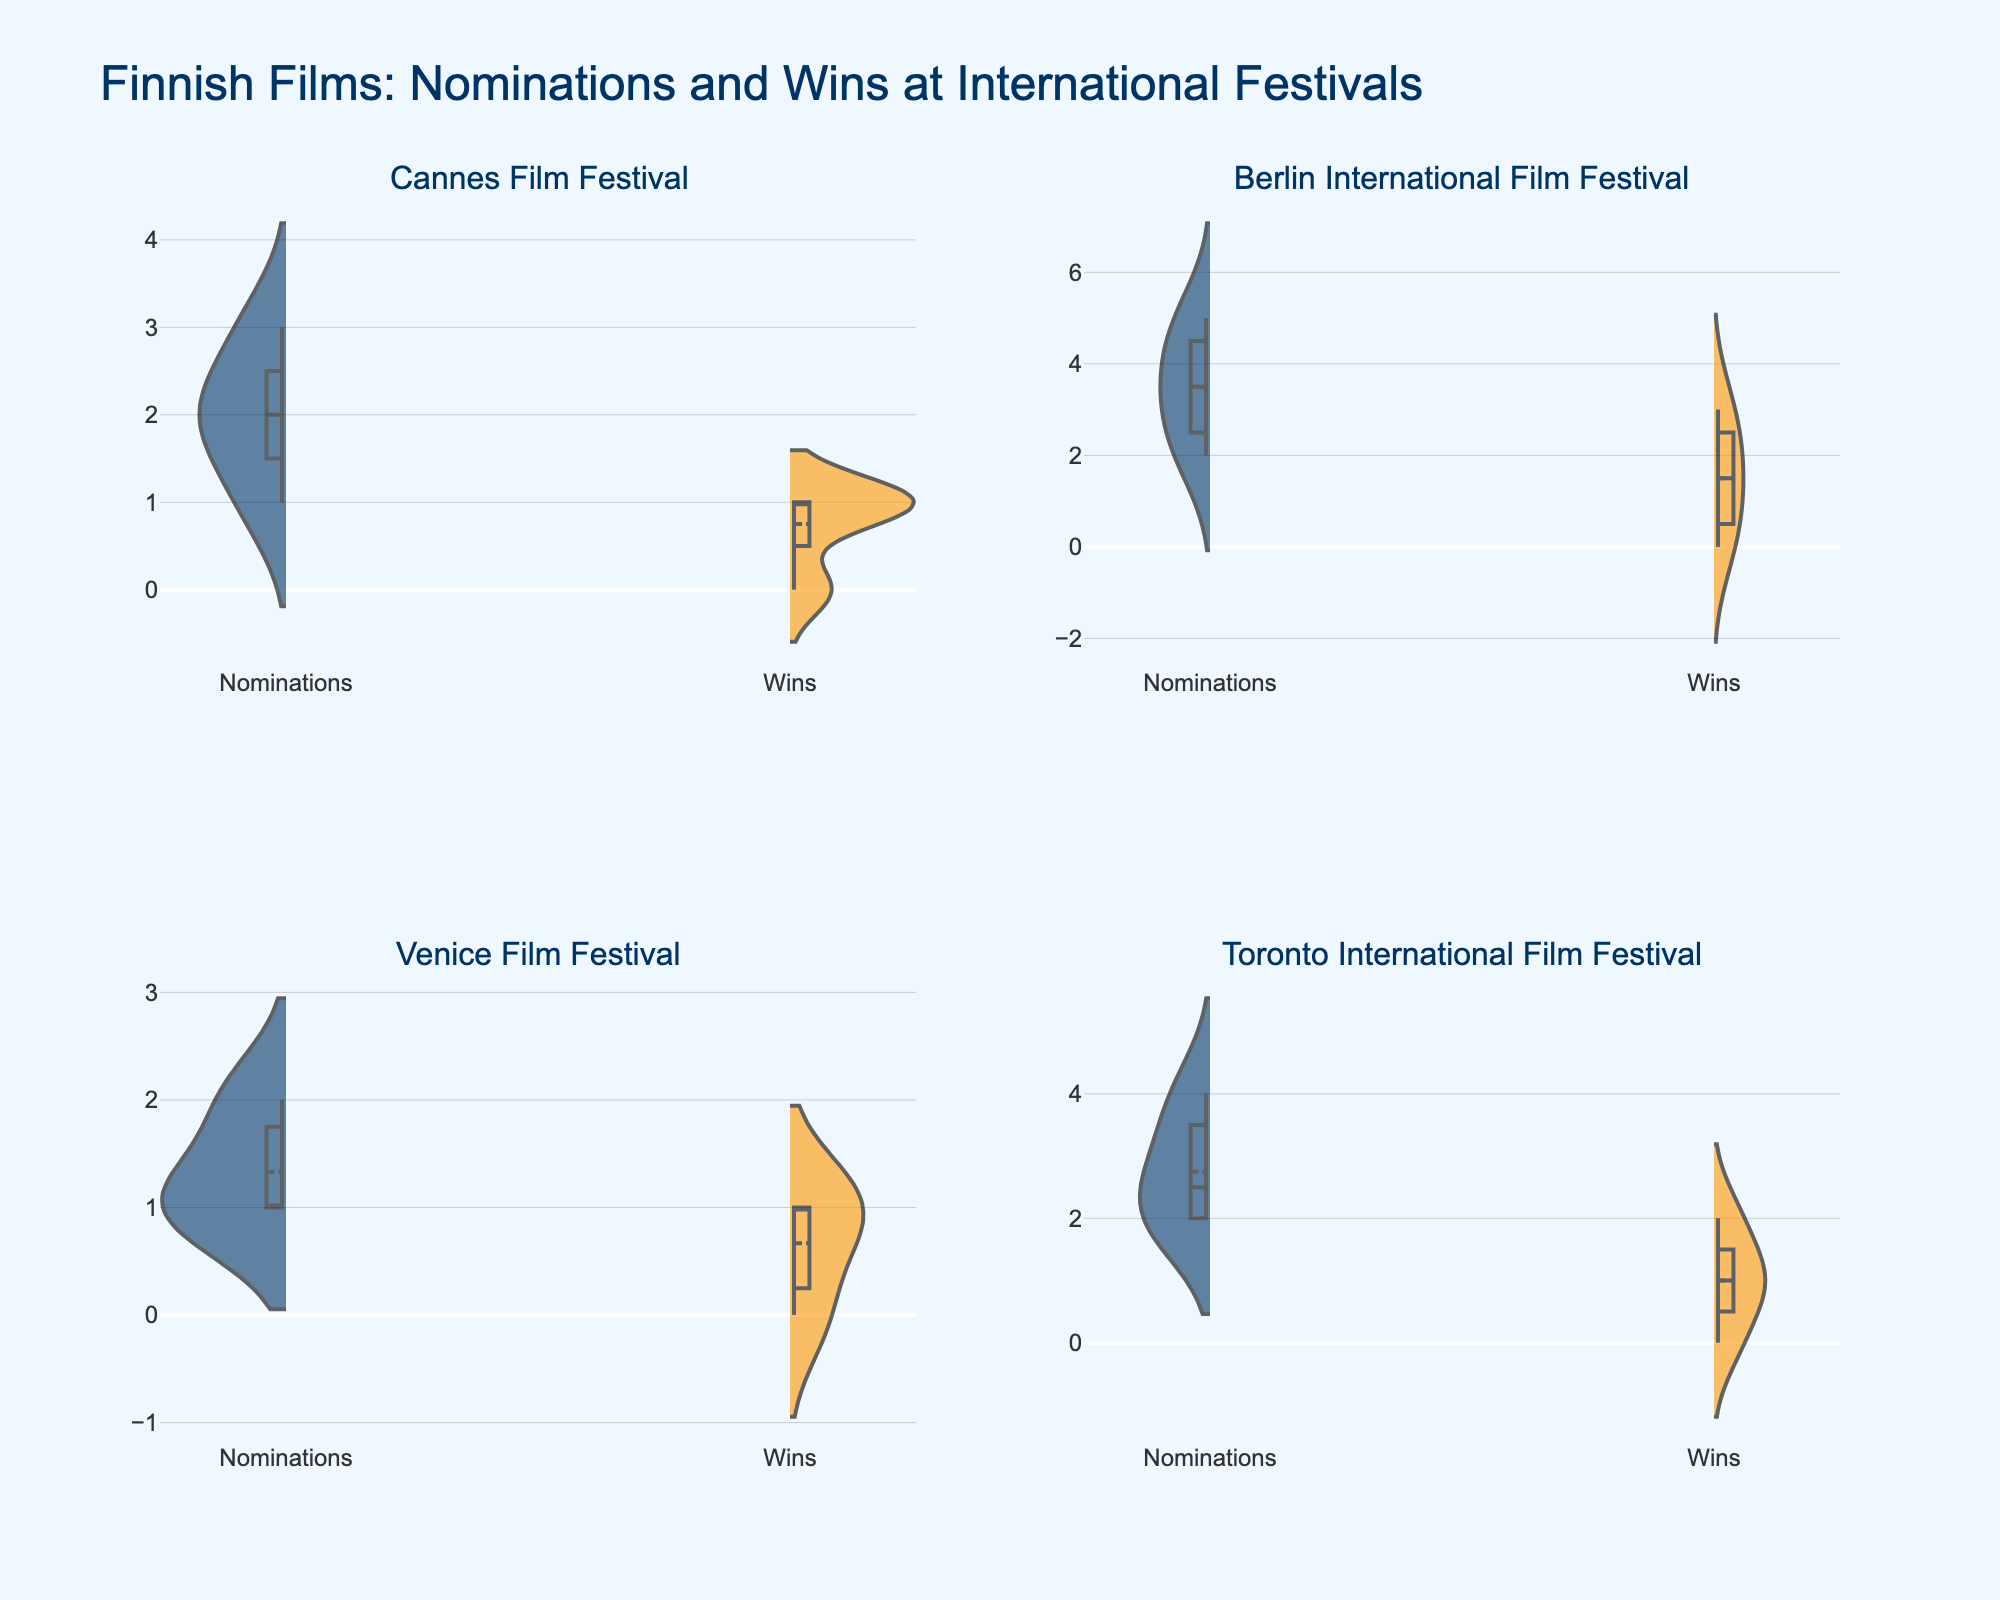What's the title of the figure? The title is typically located at the top of the figure. In this case, it reads "Finnish Films: Nominations and Wins at International Festivals".
Answer: Finnish Films: Nominations and Wins at International Festivals Which color represents wins in the violin plots? The legend or visual cues in the figure indicate which color represents which category. Here, the wins are represented by orange.
Answer: orange How many festivals are compared in this figure? The subplot titles for each violin plot indicate different festivals, and there are four subplots, each labeled with a different festival name.
Answer: four What is the festival with the highest mean number of wins? By examining the mean lines (usually bold or differently styled) in the 'Wins' violin plots, the Berlin International Film Festival displays the highest mean value for wins.
Answer: Berlin International Film Festival Which festival has the most number of nominations for a film? The maximum length of the 'Nominations' violin plot gives an idea of the highest number of nominations. The Berlin International Film Festival has a film with 5 nominations.
Answer: Berlin International Film Festival What's the median value of nominations for films in the Cannes Film Festival? The median value can be obtained from the middle of the box plot within the violin plot for 'Nominations'. For the Cannes Film Festival, the median is 2.
Answer: 2 Comparing 'Nominations', which festival shows the least spread in the data? The spread of the data in a violin plot is shown by the width. The Venice Film Festival's 'Nominations' plot appears to have the smallest spread.
Answer: Venice Film Festival Which film festival features the highest number of wins for a single film? Looking at the upper bound of the 'Wins' violin plot, 'The Man Without a Past' at the Berlin International Film Festival appears to have the highest number, with 3 wins.
Answer: Berlin International Film Festival How do the nomination distributions compare between the Cannes Film Festival and the Toronto International Film Festival? When comparing the shape and breadth of the 'Nominations' violin plots, The Cannes Film Festival has a wider spread with a range up to 3, whereas Toronto's range extends up to 4, indicating more variability and a higher maximum number for Toronto.
Answer: Toronto has a higher range and variability in nominations What does the absence of violin plot on one side indicate for any festival? An absent violin plot on one side, such as the 'side=positive' or 'side=negative', indicates no data points on that metric. For example, if 'Wins' or 'Nominations' plot is missing, that implies no nominations or wins.
Answer: No data points for absent metric 